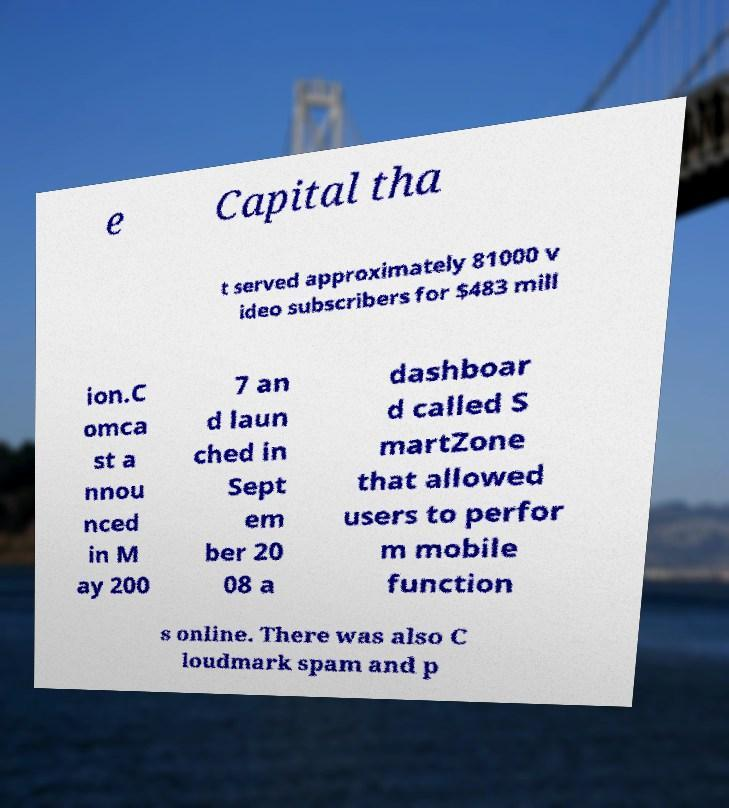There's text embedded in this image that I need extracted. Can you transcribe it verbatim? e Capital tha t served approximately 81000 v ideo subscribers for $483 mill ion.C omca st a nnou nced in M ay 200 7 an d laun ched in Sept em ber 20 08 a dashboar d called S martZone that allowed users to perfor m mobile function s online. There was also C loudmark spam and p 